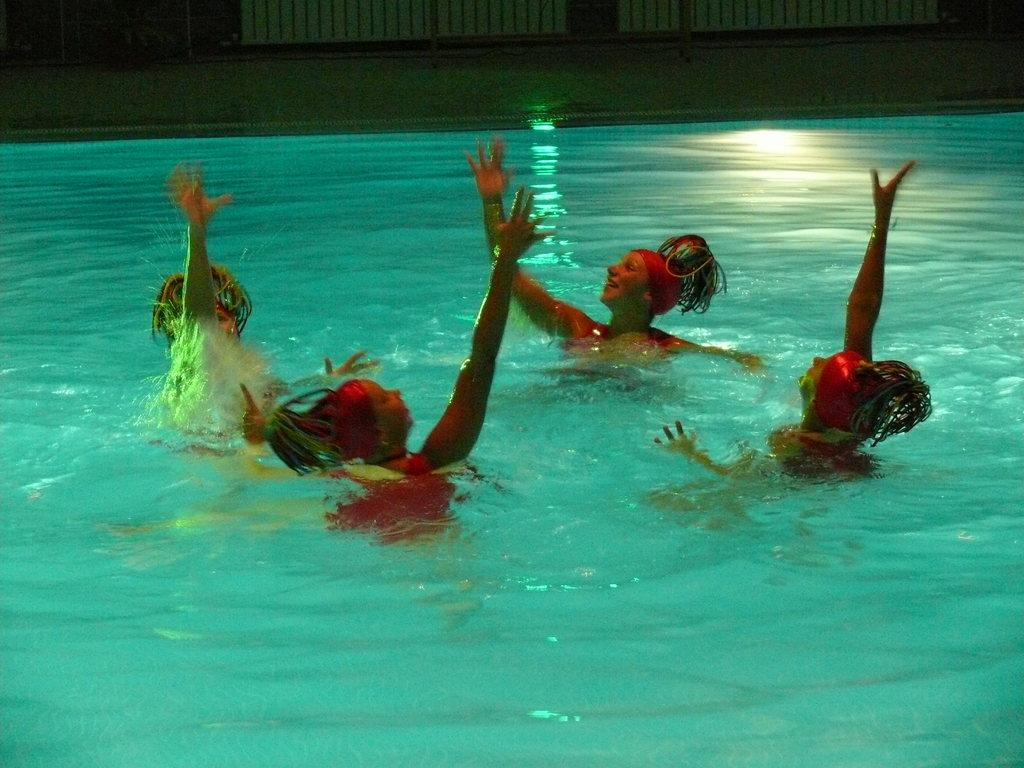How many people are in the image? There are people in the image, but the exact number is not specified. What can be seen in the background of the image? Water and unspecified objects are visible in the background of the image. Can you see any cobwebs in the image? There is no mention of cobwebs in the image, so we cannot determine if they are present or not. 